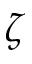<formula> <loc_0><loc_0><loc_500><loc_500>\zeta</formula> 